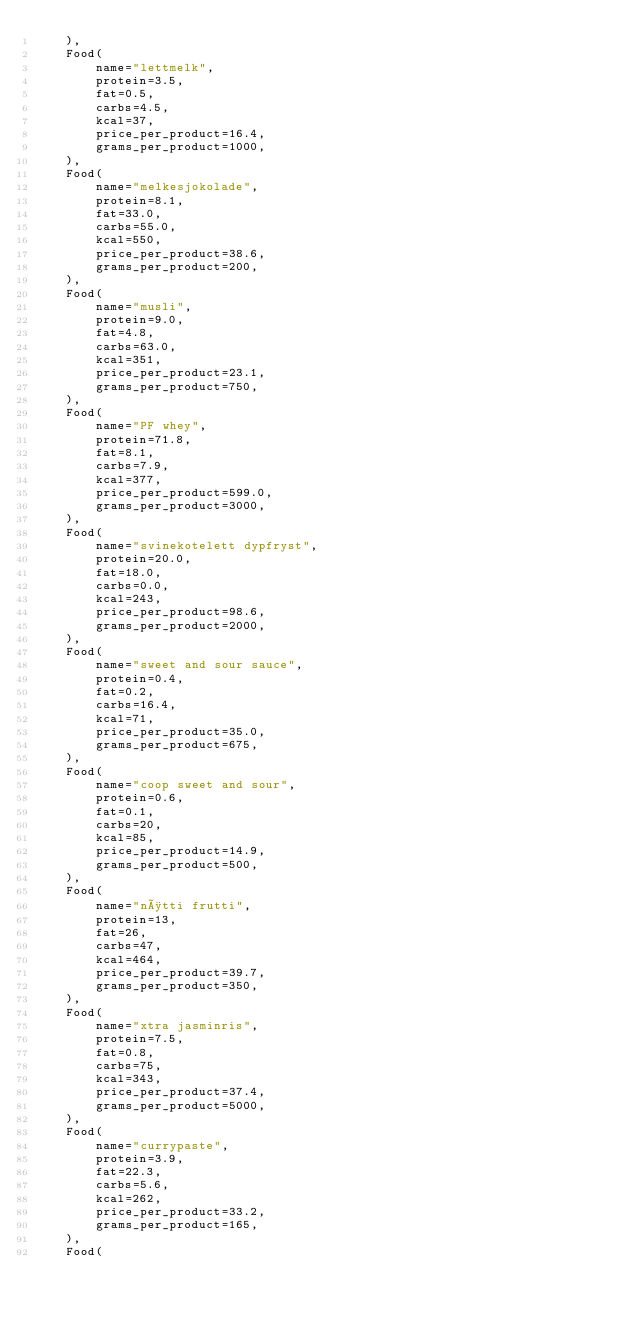Convert code to text. <code><loc_0><loc_0><loc_500><loc_500><_Python_>    ),
    Food(
        name="lettmelk",
        protein=3.5,
        fat=0.5,
        carbs=4.5,
        kcal=37,
        price_per_product=16.4,
        grams_per_product=1000,
    ),
    Food(
        name="melkesjokolade",
        protein=8.1,
        fat=33.0,
        carbs=55.0,
        kcal=550,
        price_per_product=38.6,
        grams_per_product=200,
    ),
    Food(
        name="musli",
        protein=9.0,
        fat=4.8,
        carbs=63.0,
        kcal=351,
        price_per_product=23.1,
        grams_per_product=750,
    ),
    Food(
        name="PF whey",
        protein=71.8,
        fat=8.1,
        carbs=7.9,
        kcal=377,
        price_per_product=599.0,
        grams_per_product=3000,
    ),
    Food(
        name="svinekotelett dypfryst",
        protein=20.0,
        fat=18.0,
        carbs=0.0,
        kcal=243,
        price_per_product=98.6,
        grams_per_product=2000,
    ),
    Food(
        name="sweet and sour sauce",
        protein=0.4,
        fat=0.2,
        carbs=16.4,
        kcal=71,
        price_per_product=35.0,
        grams_per_product=675,
    ),
    Food(
        name="coop sweet and sour",
        protein=0.6,
        fat=0.1,
        carbs=20,
        kcal=85,
        price_per_product=14.9,
        grams_per_product=500,
    ),
    Food(
        name="nøtti frutti",
        protein=13,
        fat=26,
        carbs=47,
        kcal=464,
        price_per_product=39.7,
        grams_per_product=350,
    ),
    Food(
        name="xtra jasminris",
        protein=7.5,
        fat=0.8,
        carbs=75,
        kcal=343,
        price_per_product=37.4,
        grams_per_product=5000,
    ),
    Food(
        name="currypaste",
        protein=3.9,
        fat=22.3,
        carbs=5.6,
        kcal=262,
        price_per_product=33.2,
        grams_per_product=165,
    ),
    Food(</code> 